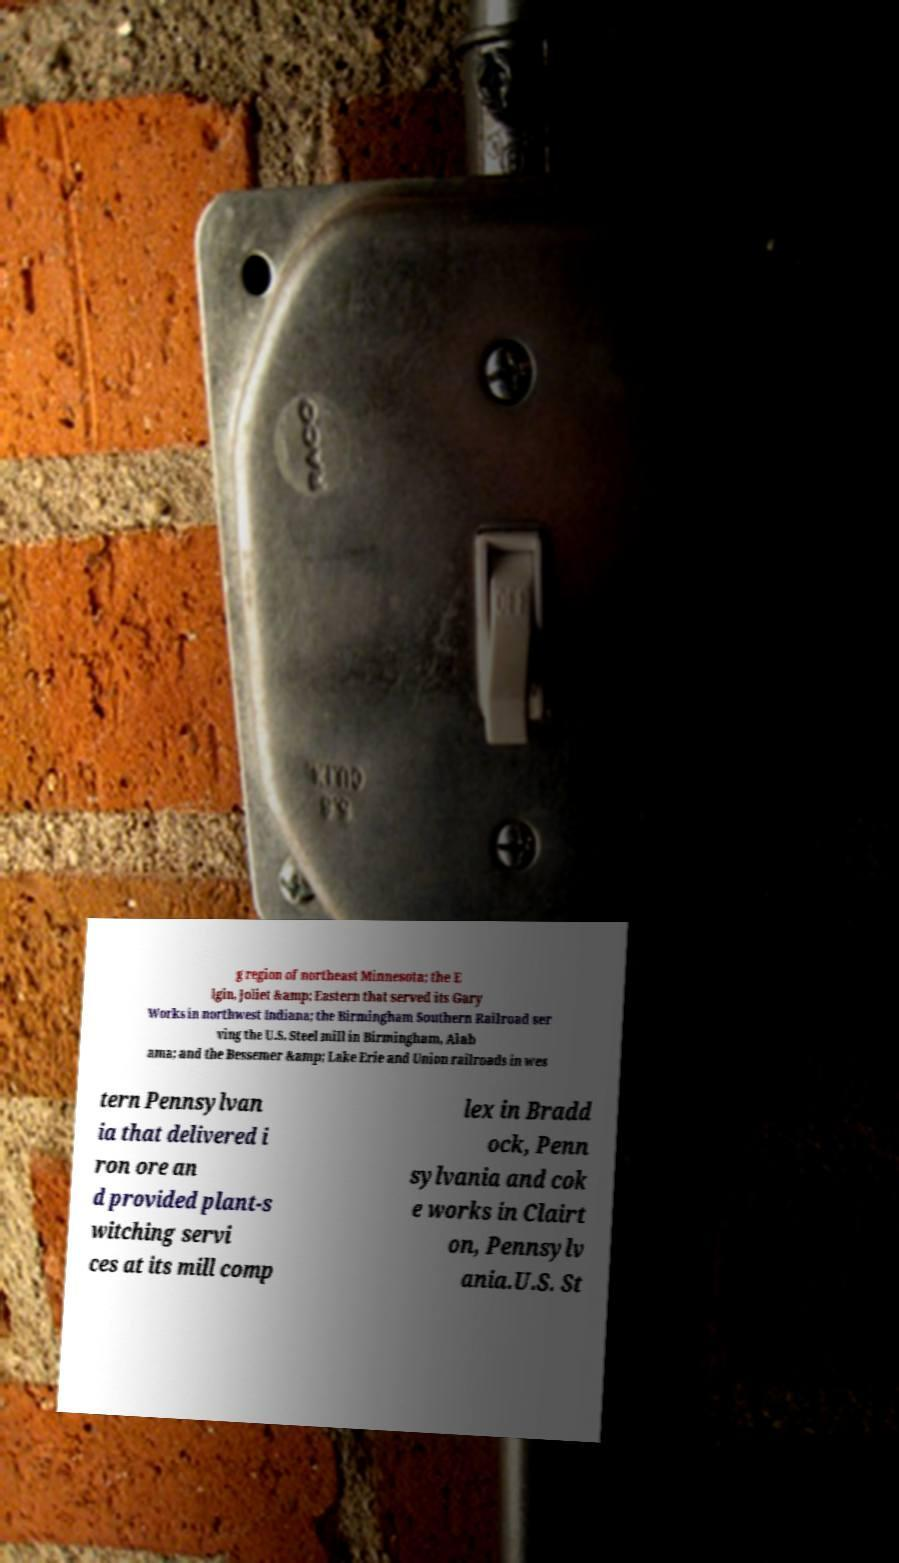Please read and relay the text visible in this image. What does it say? g region of northeast Minnesota; the E lgin, Joliet &amp; Eastern that served its Gary Works in northwest Indiana; the Birmingham Southern Railroad ser ving the U.S. Steel mill in Birmingham, Alab ama; and the Bessemer &amp; Lake Erie and Union railroads in wes tern Pennsylvan ia that delivered i ron ore an d provided plant-s witching servi ces at its mill comp lex in Bradd ock, Penn sylvania and cok e works in Clairt on, Pennsylv ania.U.S. St 